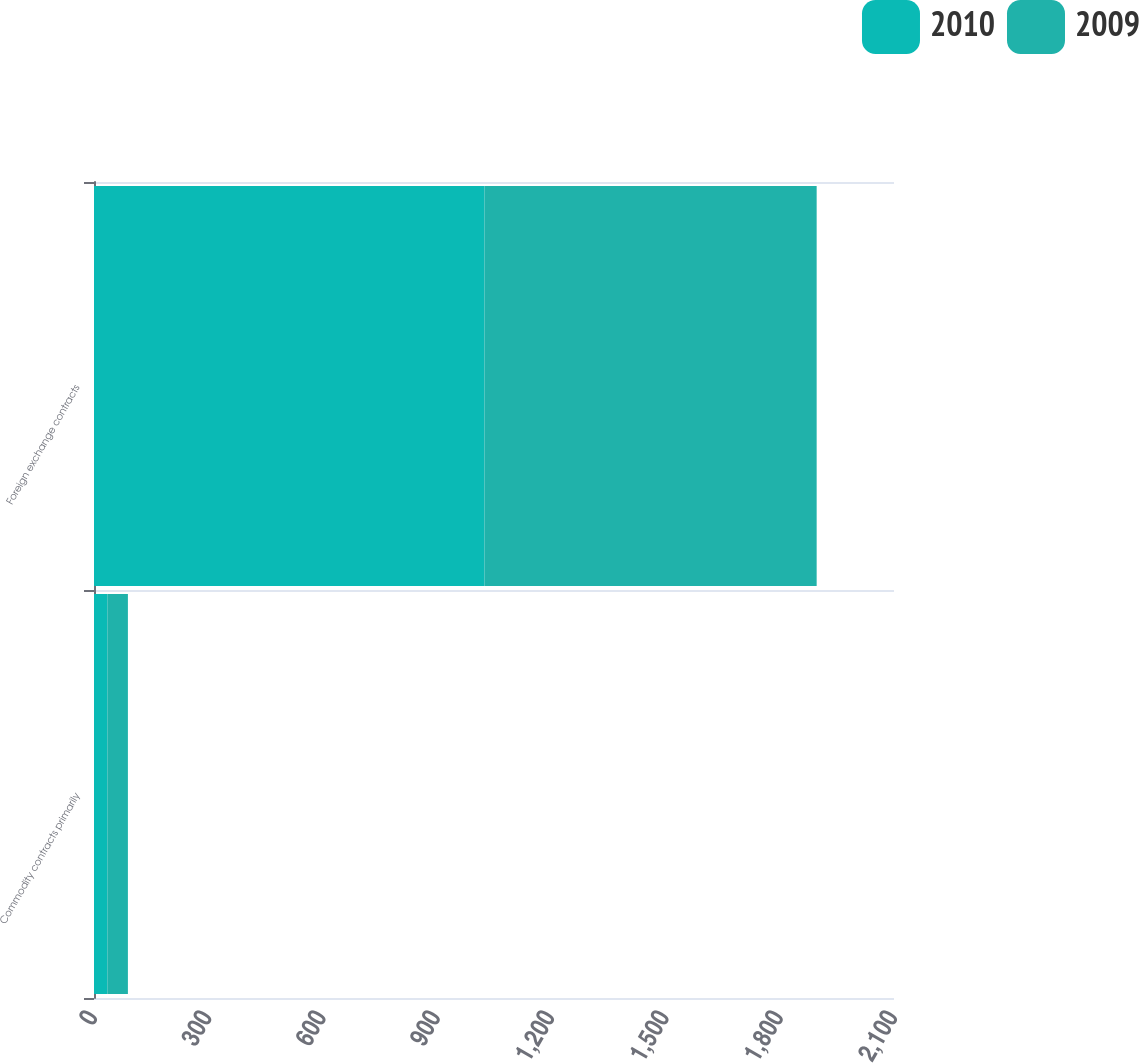<chart> <loc_0><loc_0><loc_500><loc_500><stacked_bar_chart><ecel><fcel>Commodity contracts primarily<fcel>Foreign exchange contracts<nl><fcel>2010<fcel>35<fcel>1025<nl><fcel>2009<fcel>54<fcel>872<nl></chart> 